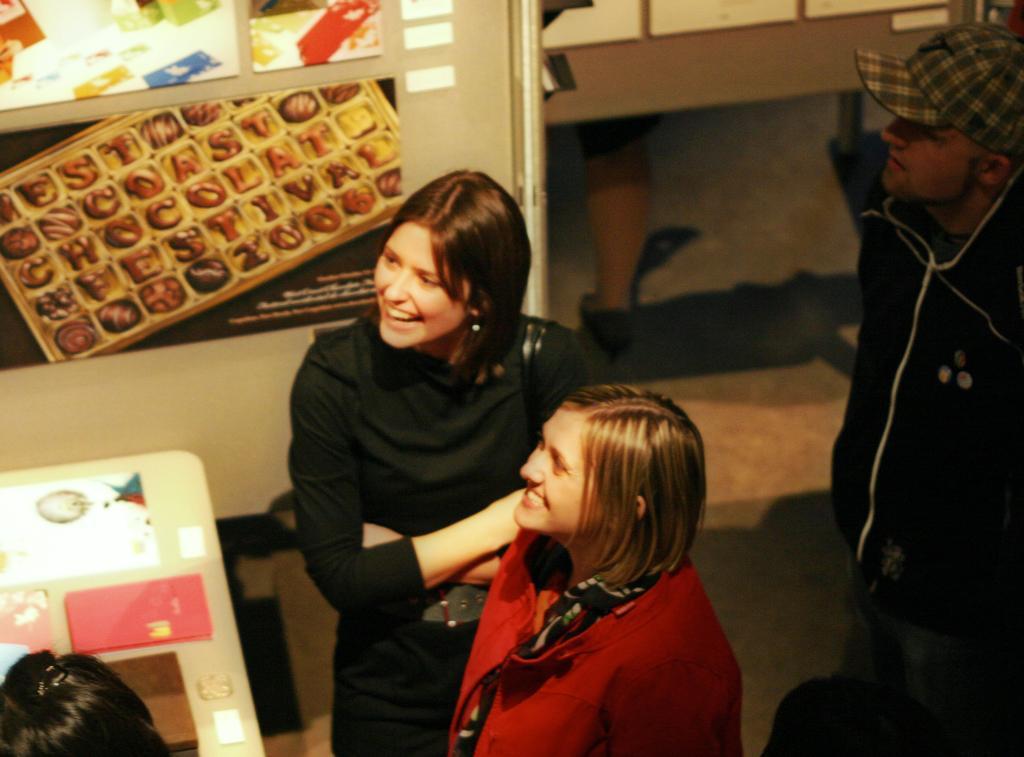Can you describe this image briefly? In the middle of the image few people are standing and smiling. In the bottom left corner of the image we can see a table, on the table we can see some papers. At the top of the image we can see a wall, on the wall we can see some posters. 